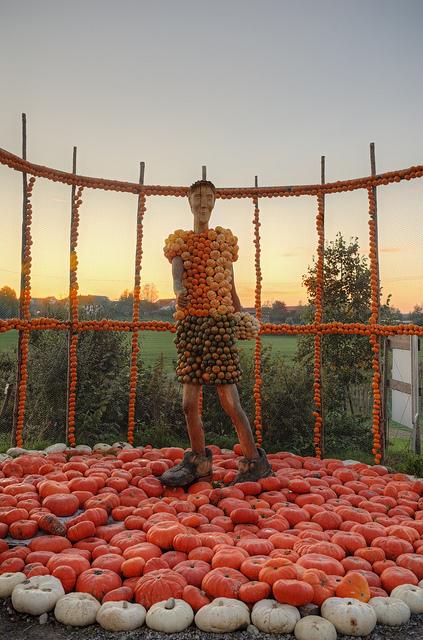What is on the ground?
Be succinct. Pumpkins. Is this a display?
Concise answer only. Yes. What vegetables are on the ground?
Concise answer only. Pumpkins. 